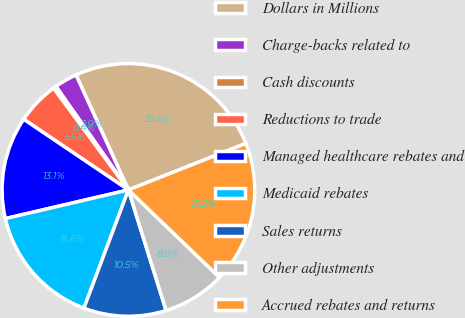Convert chart to OTSL. <chart><loc_0><loc_0><loc_500><loc_500><pie_chart><fcel>Dollars in Millions<fcel>Charge-backs related to<fcel>Cash discounts<fcel>Reductions to trade<fcel>Managed healthcare rebates and<fcel>Medicaid rebates<fcel>Sales returns<fcel>Other adjustments<fcel>Accrued rebates and returns<nl><fcel>25.81%<fcel>2.92%<fcel>0.37%<fcel>5.46%<fcel>13.09%<fcel>15.63%<fcel>10.55%<fcel>8.0%<fcel>18.18%<nl></chart> 